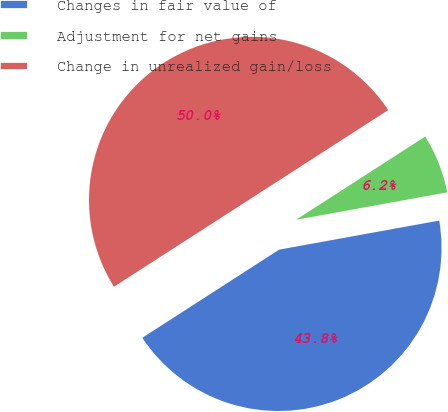Convert chart to OTSL. <chart><loc_0><loc_0><loc_500><loc_500><pie_chart><fcel>Changes in fair value of<fcel>Adjustment for net gains<fcel>Change in unrealized gain/loss<nl><fcel>43.75%<fcel>6.25%<fcel>50.0%<nl></chart> 